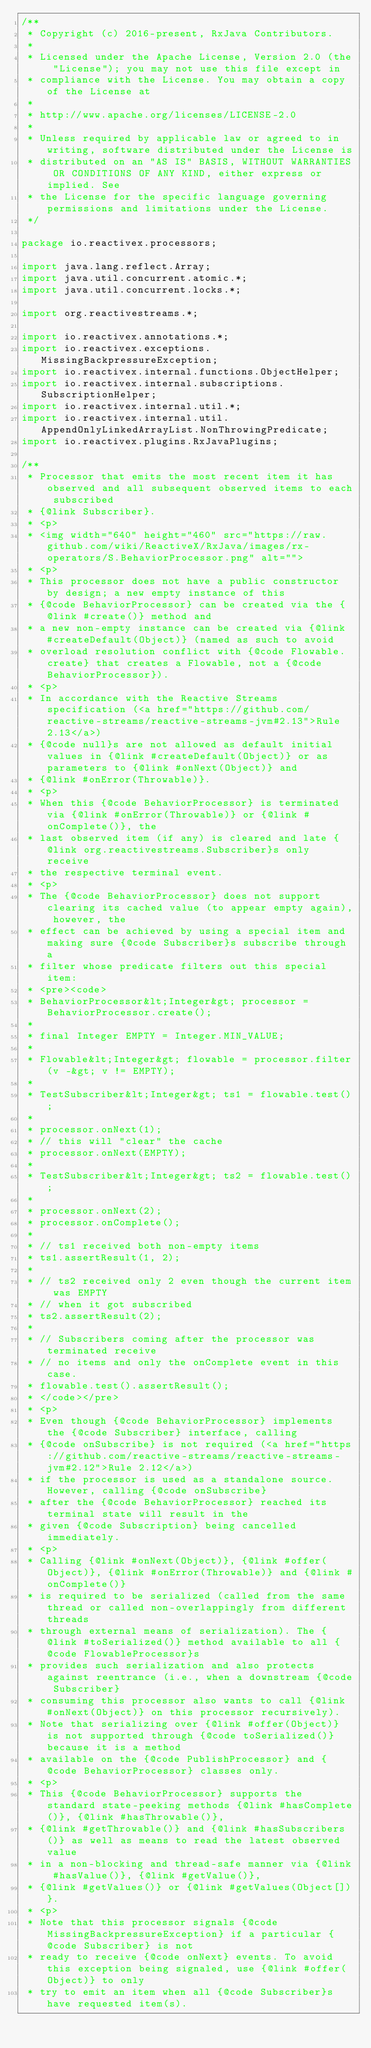<code> <loc_0><loc_0><loc_500><loc_500><_Java_>/**
 * Copyright (c) 2016-present, RxJava Contributors.
 *
 * Licensed under the Apache License, Version 2.0 (the "License"); you may not use this file except in
 * compliance with the License. You may obtain a copy of the License at
 *
 * http://www.apache.org/licenses/LICENSE-2.0
 *
 * Unless required by applicable law or agreed to in writing, software distributed under the License is
 * distributed on an "AS IS" BASIS, WITHOUT WARRANTIES OR CONDITIONS OF ANY KIND, either express or implied. See
 * the License for the specific language governing permissions and limitations under the License.
 */

package io.reactivex.processors;

import java.lang.reflect.Array;
import java.util.concurrent.atomic.*;
import java.util.concurrent.locks.*;

import org.reactivestreams.*;

import io.reactivex.annotations.*;
import io.reactivex.exceptions.MissingBackpressureException;
import io.reactivex.internal.functions.ObjectHelper;
import io.reactivex.internal.subscriptions.SubscriptionHelper;
import io.reactivex.internal.util.*;
import io.reactivex.internal.util.AppendOnlyLinkedArrayList.NonThrowingPredicate;
import io.reactivex.plugins.RxJavaPlugins;

/**
 * Processor that emits the most recent item it has observed and all subsequent observed items to each subscribed
 * {@link Subscriber}.
 * <p>
 * <img width="640" height="460" src="https://raw.github.com/wiki/ReactiveX/RxJava/images/rx-operators/S.BehaviorProcessor.png" alt="">
 * <p>
 * This processor does not have a public constructor by design; a new empty instance of this
 * {@code BehaviorProcessor} can be created via the {@link #create()} method and
 * a new non-empty instance can be created via {@link #createDefault(Object)} (named as such to avoid
 * overload resolution conflict with {@code Flowable.create} that creates a Flowable, not a {@code BehaviorProcessor}).
 * <p>
 * In accordance with the Reactive Streams specification (<a href="https://github.com/reactive-streams/reactive-streams-jvm#2.13">Rule 2.13</a>)
 * {@code null}s are not allowed as default initial values in {@link #createDefault(Object)} or as parameters to {@link #onNext(Object)} and
 * {@link #onError(Throwable)}.
 * <p>
 * When this {@code BehaviorProcessor} is terminated via {@link #onError(Throwable)} or {@link #onComplete()}, the
 * last observed item (if any) is cleared and late {@link org.reactivestreams.Subscriber}s only receive
 * the respective terminal event.
 * <p>
 * The {@code BehaviorProcessor} does not support clearing its cached value (to appear empty again), however, the
 * effect can be achieved by using a special item and making sure {@code Subscriber}s subscribe through a
 * filter whose predicate filters out this special item:
 * <pre><code>
 * BehaviorProcessor&lt;Integer&gt; processor = BehaviorProcessor.create();
 *
 * final Integer EMPTY = Integer.MIN_VALUE;
 *
 * Flowable&lt;Integer&gt; flowable = processor.filter(v -&gt; v != EMPTY);
 *
 * TestSubscriber&lt;Integer&gt; ts1 = flowable.test();
 *
 * processor.onNext(1);
 * // this will "clear" the cache
 * processor.onNext(EMPTY);
 * 
 * TestSubscriber&lt;Integer&gt; ts2 = flowable.test();
 * 
 * processor.onNext(2);
 * processor.onComplete();
 * 
 * // ts1 received both non-empty items
 * ts1.assertResult(1, 2);
 * 
 * // ts2 received only 2 even though the current item was EMPTY
 * // when it got subscribed
 * ts2.assertResult(2);
 * 
 * // Subscribers coming after the processor was terminated receive
 * // no items and only the onComplete event in this case.
 * flowable.test().assertResult();
 * </code></pre>
 * <p>
 * Even though {@code BehaviorProcessor} implements the {@code Subscriber} interface, calling
 * {@code onSubscribe} is not required (<a href="https://github.com/reactive-streams/reactive-streams-jvm#2.12">Rule 2.12</a>)
 * if the processor is used as a standalone source. However, calling {@code onSubscribe}
 * after the {@code BehaviorProcessor} reached its terminal state will result in the
 * given {@code Subscription} being cancelled immediately.
 * <p>
 * Calling {@link #onNext(Object)}, {@link #offer(Object)}, {@link #onError(Throwable)} and {@link #onComplete()}
 * is required to be serialized (called from the same thread or called non-overlappingly from different threads
 * through external means of serialization). The {@link #toSerialized()} method available to all {@code FlowableProcessor}s
 * provides such serialization and also protects against reentrance (i.e., when a downstream {@code Subscriber}
 * consuming this processor also wants to call {@link #onNext(Object)} on this processor recursively).
 * Note that serializing over {@link #offer(Object)} is not supported through {@code toSerialized()} because it is a method
 * available on the {@code PublishProcessor} and {@code BehaviorProcessor} classes only.
 * <p>
 * This {@code BehaviorProcessor} supports the standard state-peeking methods {@link #hasComplete()}, {@link #hasThrowable()},
 * {@link #getThrowable()} and {@link #hasSubscribers()} as well as means to read the latest observed value
 * in a non-blocking and thread-safe manner via {@link #hasValue()}, {@link #getValue()},
 * {@link #getValues()} or {@link #getValues(Object[])}.
 * <p>
 * Note that this processor signals {@code MissingBackpressureException} if a particular {@code Subscriber} is not
 * ready to receive {@code onNext} events. To avoid this exception being signaled, use {@link #offer(Object)} to only
 * try to emit an item when all {@code Subscriber}s have requested item(s).</code> 